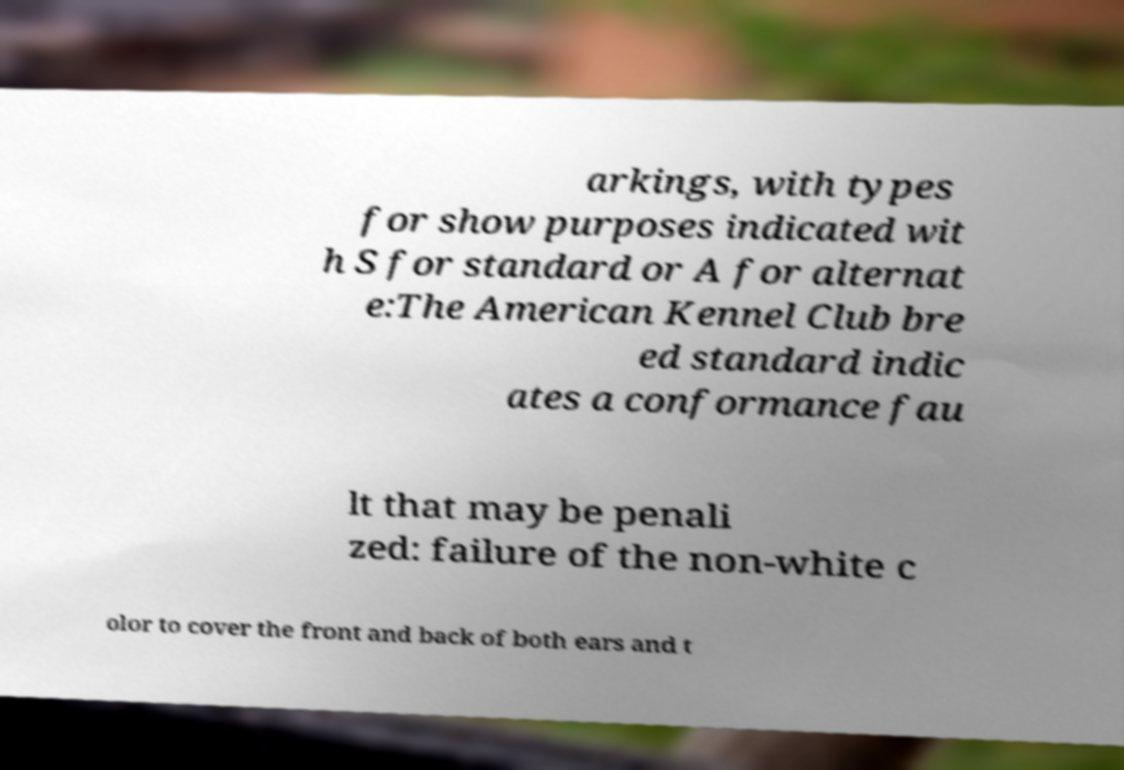What messages or text are displayed in this image? I need them in a readable, typed format. arkings, with types for show purposes indicated wit h S for standard or A for alternat e:The American Kennel Club bre ed standard indic ates a conformance fau lt that may be penali zed: failure of the non-white c olor to cover the front and back of both ears and t 